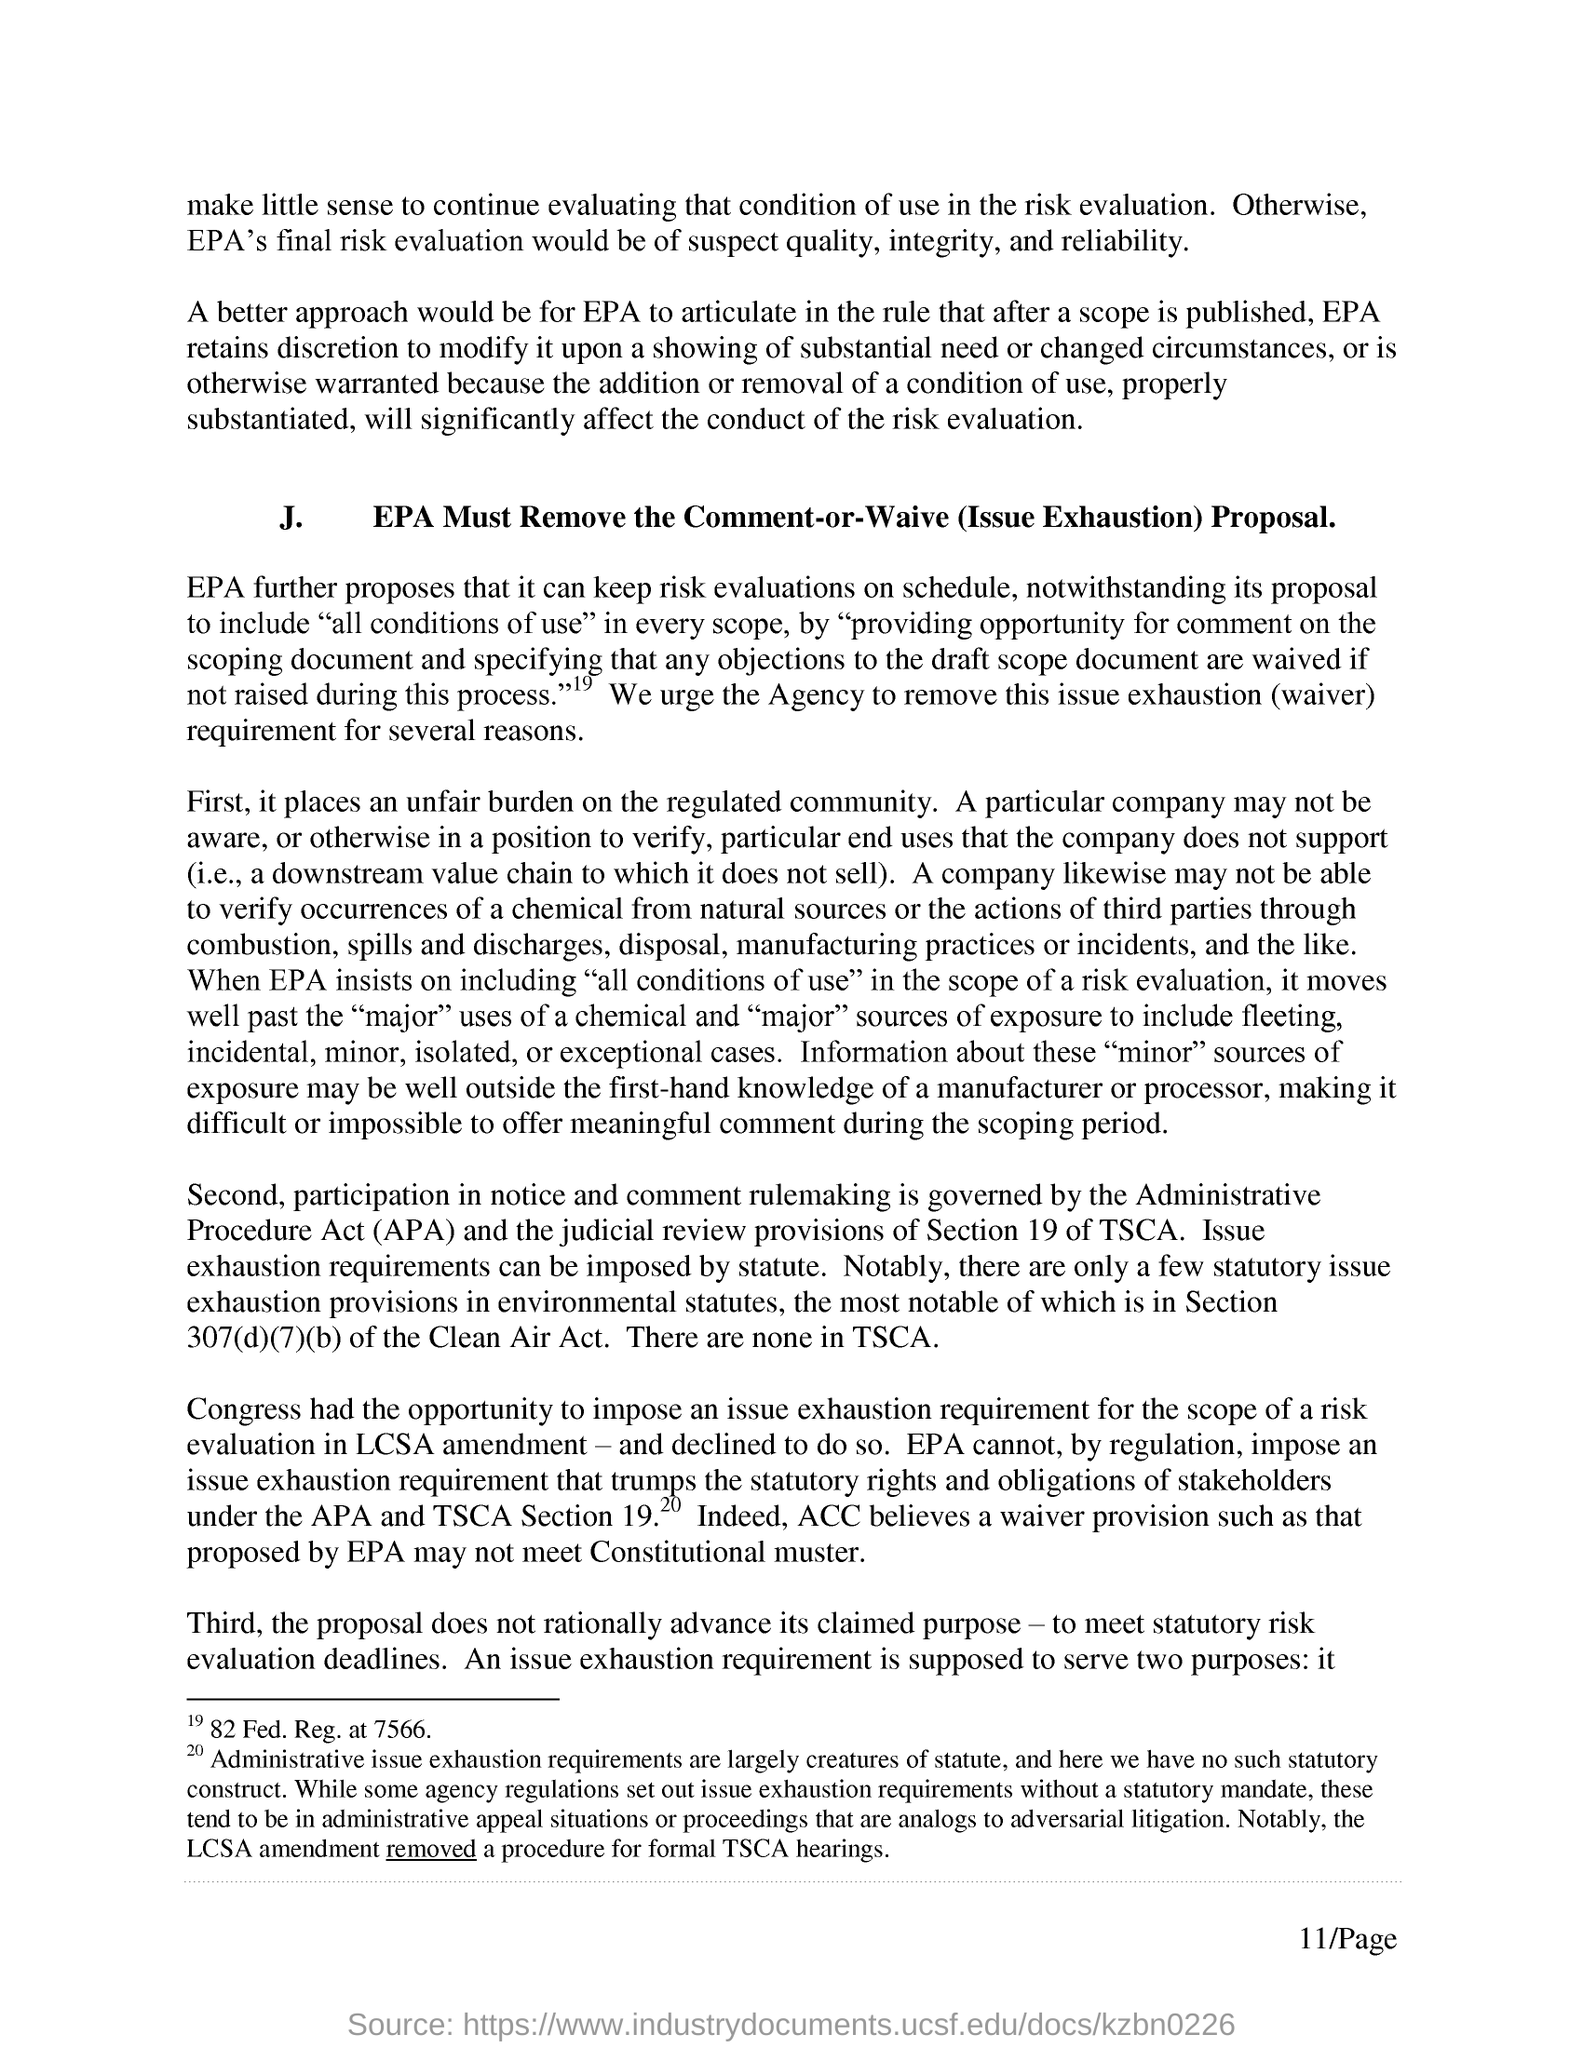What would be the epa's final risk evaluation?
Make the answer very short. Suspect quality, integrity, and reliability. What does apa stands for?
Give a very brief answer. Administrative Procedure Act. Which section is for judicial review provisions of tsca?
Your response must be concise. Section 19. Which section is for issue exhaustion provisions in environmentional statues?
Keep it short and to the point. Section 307(d)(7)(b) of the Clean Air Act. Which act is for section 307(d)(7)(b)?
Give a very brief answer. Clean Air Act. 